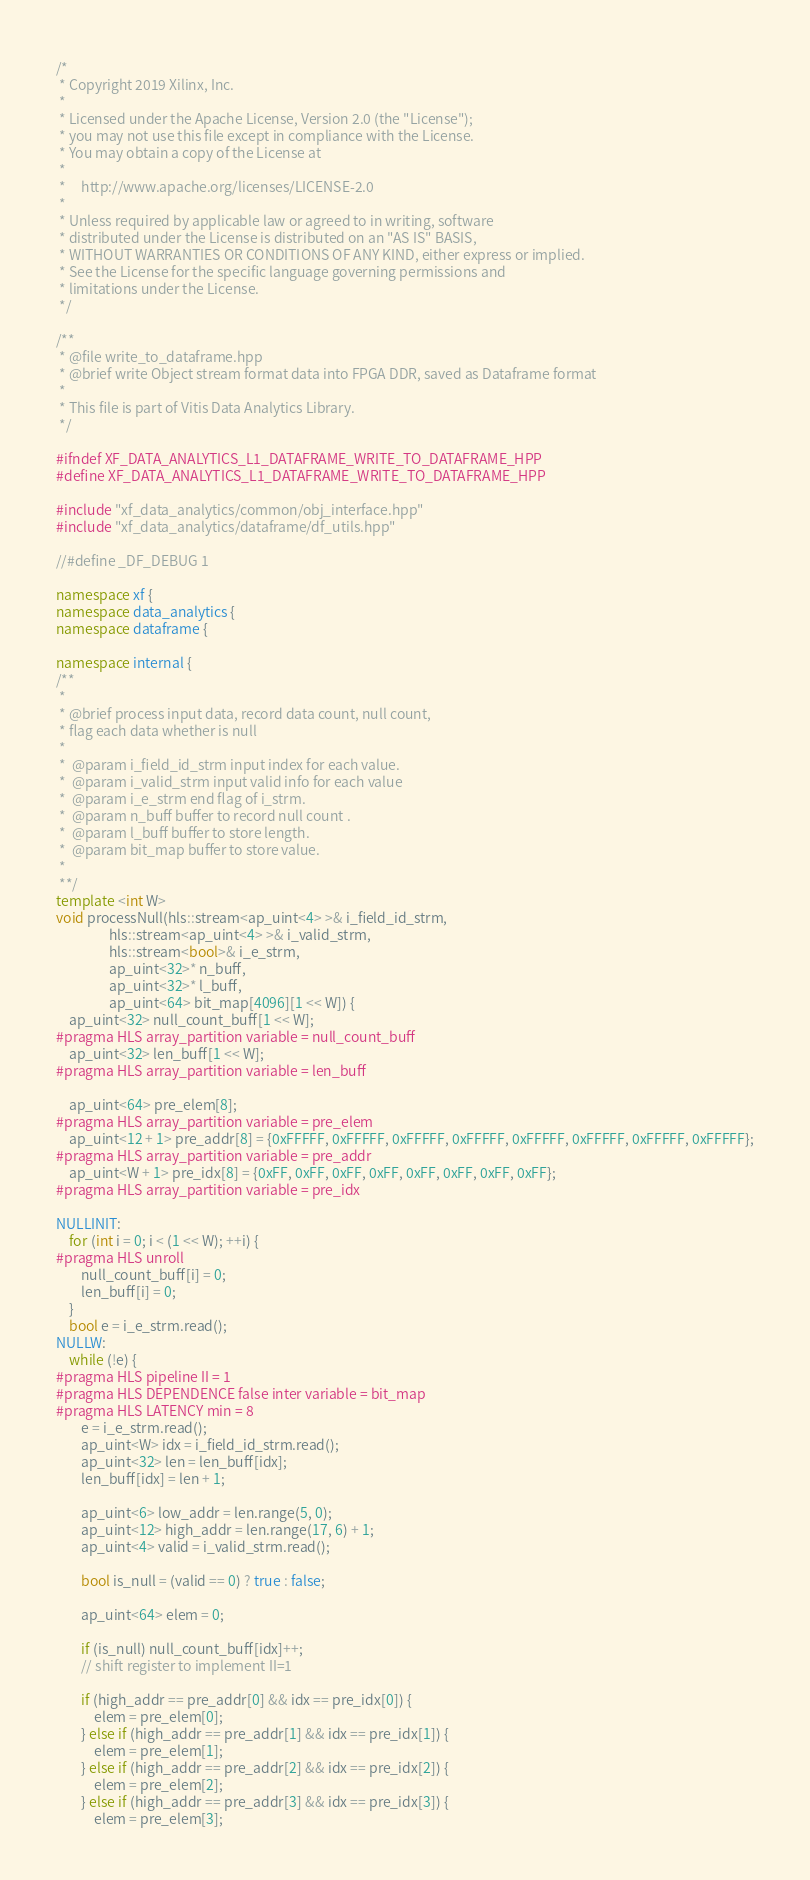Convert code to text. <code><loc_0><loc_0><loc_500><loc_500><_C++_>/*
 * Copyright 2019 Xilinx, Inc.
 *
 * Licensed under the Apache License, Version 2.0 (the "License");
 * you may not use this file except in compliance with the License.
 * You may obtain a copy of the License at
 *
 *     http://www.apache.org/licenses/LICENSE-2.0
 *
 * Unless required by applicable law or agreed to in writing, software
 * distributed under the License is distributed on an "AS IS" BASIS,
 * WITHOUT WARRANTIES OR CONDITIONS OF ANY KIND, either express or implied.
 * See the License for the specific language governing permissions and
 * limitations under the License.
 */

/**
 * @file write_to_dataframe.hpp
 * @brief write Object stream format data into FPGA DDR, saved as Dataframe format
 *
 * This file is part of Vitis Data Analytics Library.
 */

#ifndef XF_DATA_ANALYTICS_L1_DATAFRAME_WRITE_TO_DATAFRAME_HPP
#define XF_DATA_ANALYTICS_L1_DATAFRAME_WRITE_TO_DATAFRAME_HPP

#include "xf_data_analytics/common/obj_interface.hpp"
#include "xf_data_analytics/dataframe/df_utils.hpp"

//#define _DF_DEBUG 1

namespace xf {
namespace data_analytics {
namespace dataframe {

namespace internal {
/**
 *
 * @brief process input data, record data count, null count,
 * flag each data whether is null
 *
 *  @param i_field_id_strm input index for each value.
 *  @param i_valid_strm input valid info for each value
 *  @param i_e_strm end flag of i_strm.
 *  @param n_buff buffer to record null count .
 *  @param l_buff buffer to store length.
 *  @param bit_map buffer to store value.
 *
 **/
template <int W>
void processNull(hls::stream<ap_uint<4> >& i_field_id_strm,
                 hls::stream<ap_uint<4> >& i_valid_strm,
                 hls::stream<bool>& i_e_strm,
                 ap_uint<32>* n_buff,
                 ap_uint<32>* l_buff,
                 ap_uint<64> bit_map[4096][1 << W]) {
    ap_uint<32> null_count_buff[1 << W];
#pragma HLS array_partition variable = null_count_buff
    ap_uint<32> len_buff[1 << W];
#pragma HLS array_partition variable = len_buff

    ap_uint<64> pre_elem[8];
#pragma HLS array_partition variable = pre_elem
    ap_uint<12 + 1> pre_addr[8] = {0xFFFFF, 0xFFFFF, 0xFFFFF, 0xFFFFF, 0xFFFFF, 0xFFFFF, 0xFFFFF, 0xFFFFF};
#pragma HLS array_partition variable = pre_addr
    ap_uint<W + 1> pre_idx[8] = {0xFF, 0xFF, 0xFF, 0xFF, 0xFF, 0xFF, 0xFF, 0xFF};
#pragma HLS array_partition variable = pre_idx

NULLINIT:
    for (int i = 0; i < (1 << W); ++i) {
#pragma HLS unroll
        null_count_buff[i] = 0;
        len_buff[i] = 0;
    }
    bool e = i_e_strm.read();
NULLW:
    while (!e) {
#pragma HLS pipeline II = 1
#pragma HLS DEPENDENCE false inter variable = bit_map
#pragma HLS LATENCY min = 8
        e = i_e_strm.read();
        ap_uint<W> idx = i_field_id_strm.read();
        ap_uint<32> len = len_buff[idx];
        len_buff[idx] = len + 1;

        ap_uint<6> low_addr = len.range(5, 0);
        ap_uint<12> high_addr = len.range(17, 6) + 1;
        ap_uint<4> valid = i_valid_strm.read();

        bool is_null = (valid == 0) ? true : false;

        ap_uint<64> elem = 0;

        if (is_null) null_count_buff[idx]++;
        // shift register to implement II=1

        if (high_addr == pre_addr[0] && idx == pre_idx[0]) {
            elem = pre_elem[0];
        } else if (high_addr == pre_addr[1] && idx == pre_idx[1]) {
            elem = pre_elem[1];
        } else if (high_addr == pre_addr[2] && idx == pre_idx[2]) {
            elem = pre_elem[2];
        } else if (high_addr == pre_addr[3] && idx == pre_idx[3]) {
            elem = pre_elem[3];</code> 